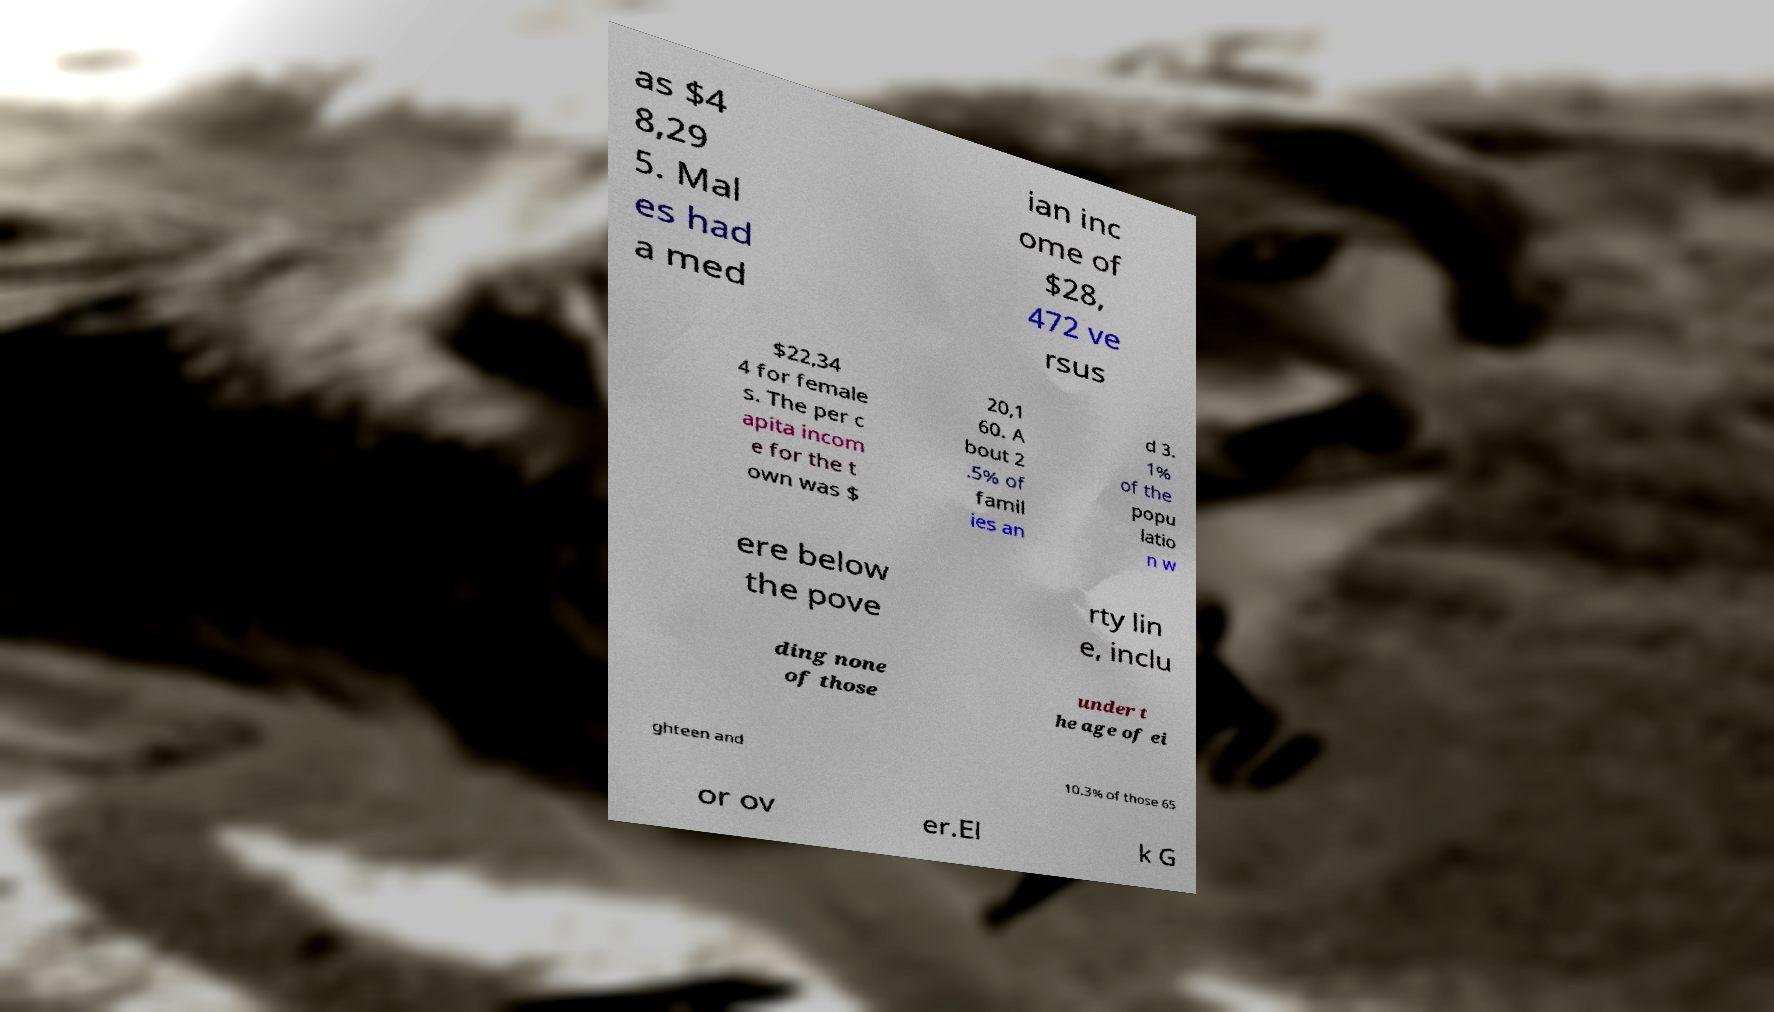Could you assist in decoding the text presented in this image and type it out clearly? as $4 8,29 5. Mal es had a med ian inc ome of $28, 472 ve rsus $22,34 4 for female s. The per c apita incom e for the t own was $ 20,1 60. A bout 2 .5% of famil ies an d 3. 1% of the popu latio n w ere below the pove rty lin e, inclu ding none of those under t he age of ei ghteen and 10.3% of those 65 or ov er.El k G 